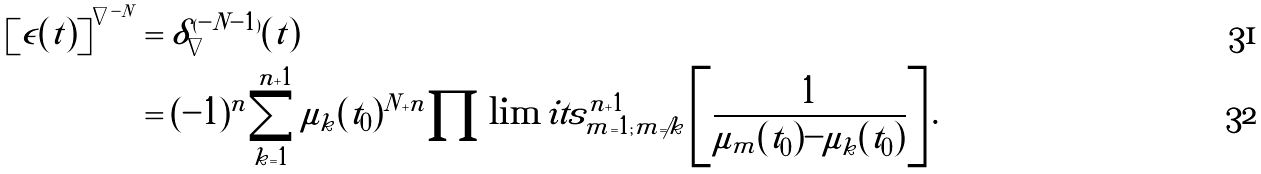Convert formula to latex. <formula><loc_0><loc_0><loc_500><loc_500>\left [ \epsilon ( t ) \right ] ^ { \nabla ^ { - N } } & = \delta _ { \nabla } ^ { ( - N - 1 ) } ( t ) \\ & = ( - 1 ) ^ { n } \sum _ { k = 1 } ^ { n + 1 } \mu _ { k } ( t _ { 0 } ) ^ { N + n } \prod \lim i t s _ { m = 1 ; m \ne k } ^ { n + 1 } \left [ \frac { 1 } { \mu _ { m } ( t _ { 0 } ) - \mu _ { k } ( t _ { 0 } ) } \right ] .</formula> 